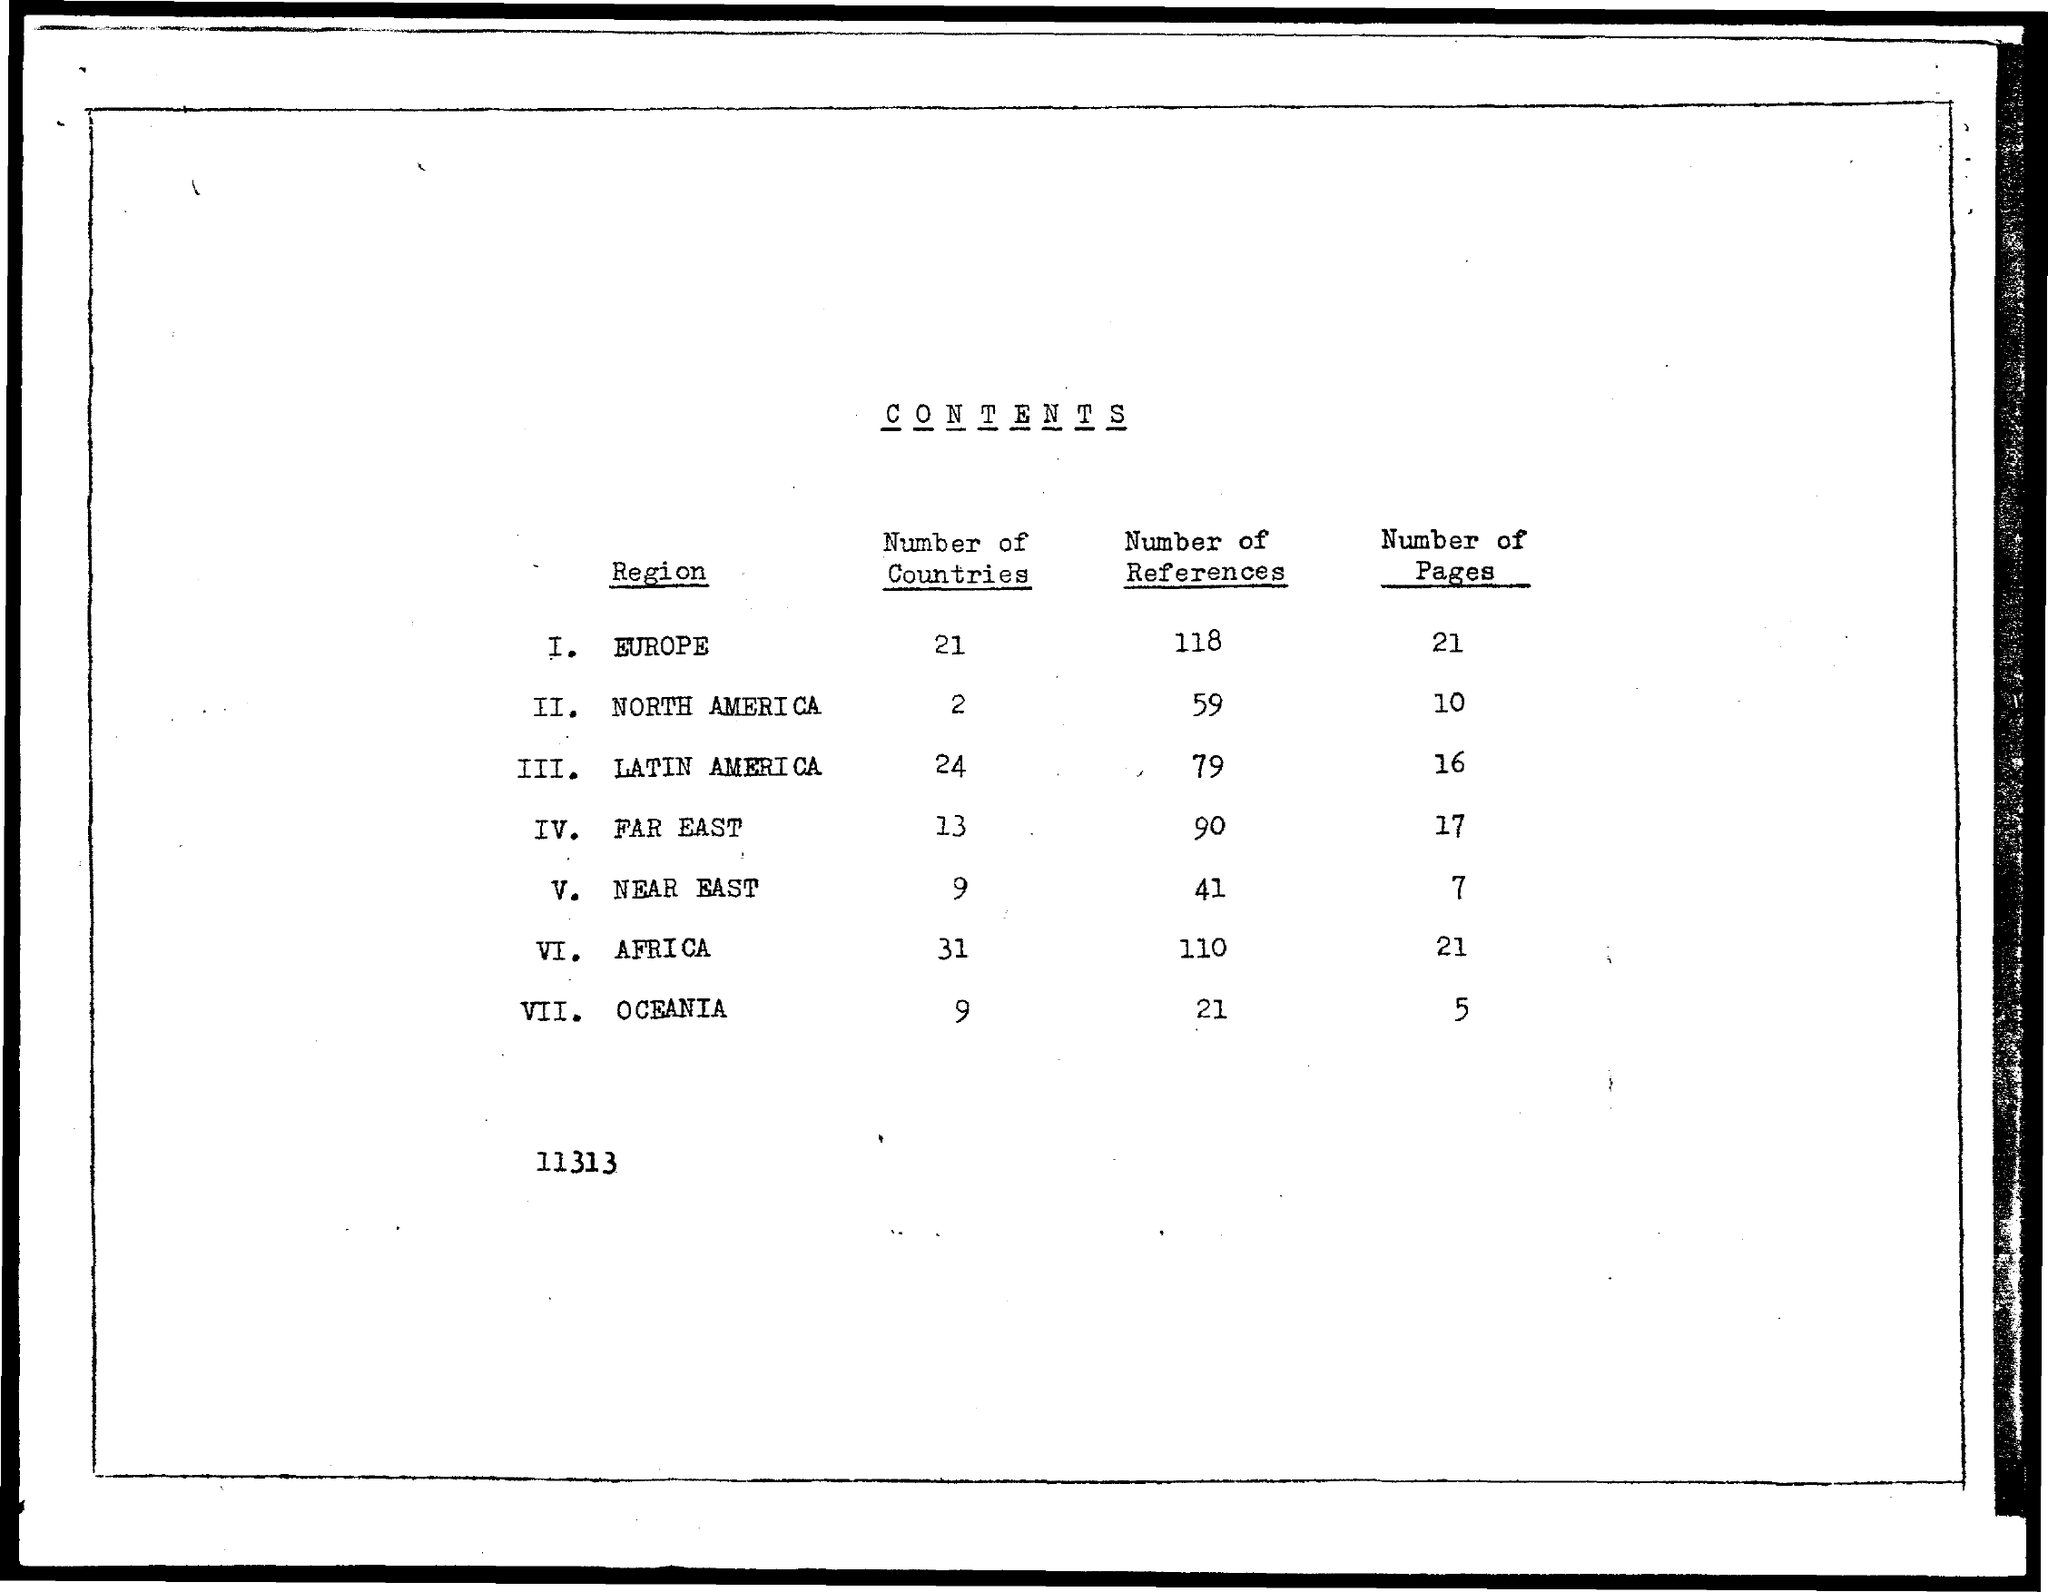Indicate a few pertinent items in this graphic. There are 59 references for North America. The number of references for Oceania is 21. There are 79 references in total for Latin America. Forty-one references were found in the Near East. There are 110 references in total for Africa. 